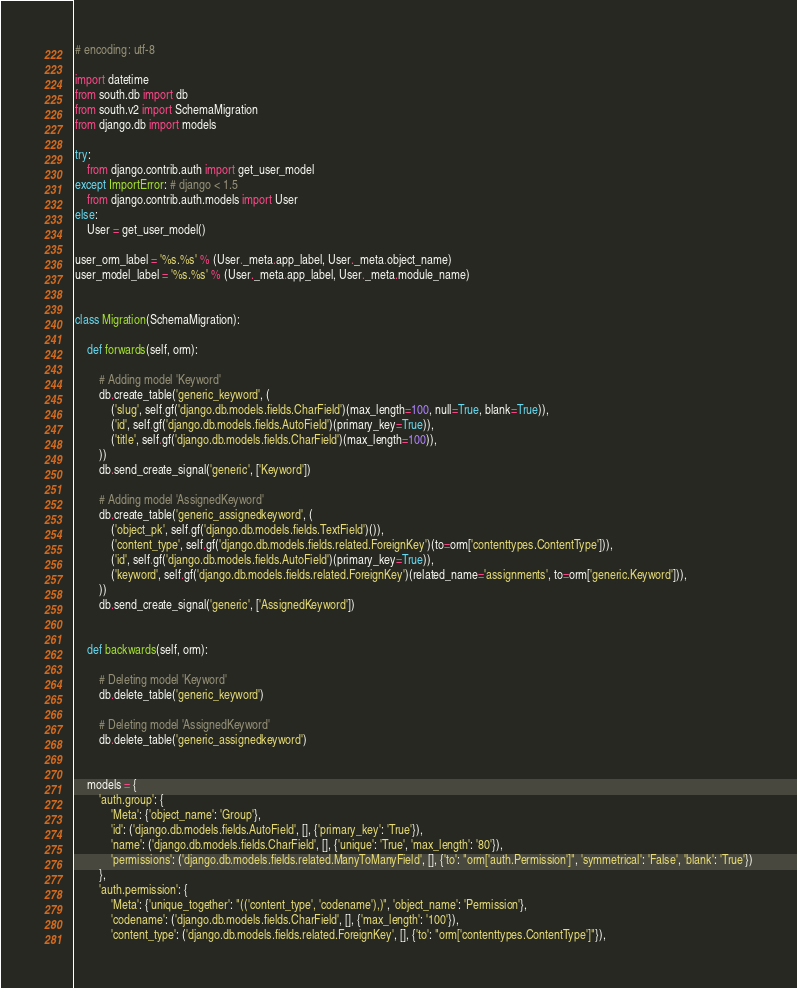<code> <loc_0><loc_0><loc_500><loc_500><_Python_># encoding: utf-8

import datetime
from south.db import db
from south.v2 import SchemaMigration
from django.db import models

try:
    from django.contrib.auth import get_user_model
except ImportError: # django < 1.5
    from django.contrib.auth.models import User
else:
    User = get_user_model()

user_orm_label = '%s.%s' % (User._meta.app_label, User._meta.object_name)
user_model_label = '%s.%s' % (User._meta.app_label, User._meta.module_name)


class Migration(SchemaMigration):

    def forwards(self, orm):

        # Adding model 'Keyword'
        db.create_table('generic_keyword', (
            ('slug', self.gf('django.db.models.fields.CharField')(max_length=100, null=True, blank=True)),
            ('id', self.gf('django.db.models.fields.AutoField')(primary_key=True)),
            ('title', self.gf('django.db.models.fields.CharField')(max_length=100)),
        ))
        db.send_create_signal('generic', ['Keyword'])

        # Adding model 'AssignedKeyword'
        db.create_table('generic_assignedkeyword', (
            ('object_pk', self.gf('django.db.models.fields.TextField')()),
            ('content_type', self.gf('django.db.models.fields.related.ForeignKey')(to=orm['contenttypes.ContentType'])),
            ('id', self.gf('django.db.models.fields.AutoField')(primary_key=True)),
            ('keyword', self.gf('django.db.models.fields.related.ForeignKey')(related_name='assignments', to=orm['generic.Keyword'])),
        ))
        db.send_create_signal('generic', ['AssignedKeyword'])


    def backwards(self, orm):

        # Deleting model 'Keyword'
        db.delete_table('generic_keyword')

        # Deleting model 'AssignedKeyword'
        db.delete_table('generic_assignedkeyword')


    models = {
        'auth.group': {
            'Meta': {'object_name': 'Group'},
            'id': ('django.db.models.fields.AutoField', [], {'primary_key': 'True'}),
            'name': ('django.db.models.fields.CharField', [], {'unique': 'True', 'max_length': '80'}),
            'permissions': ('django.db.models.fields.related.ManyToManyField', [], {'to': "orm['auth.Permission']", 'symmetrical': 'False', 'blank': 'True'})
        },
        'auth.permission': {
            'Meta': {'unique_together': "(('content_type', 'codename'),)", 'object_name': 'Permission'},
            'codename': ('django.db.models.fields.CharField', [], {'max_length': '100'}),
            'content_type': ('django.db.models.fields.related.ForeignKey', [], {'to': "orm['contenttypes.ContentType']"}),</code> 